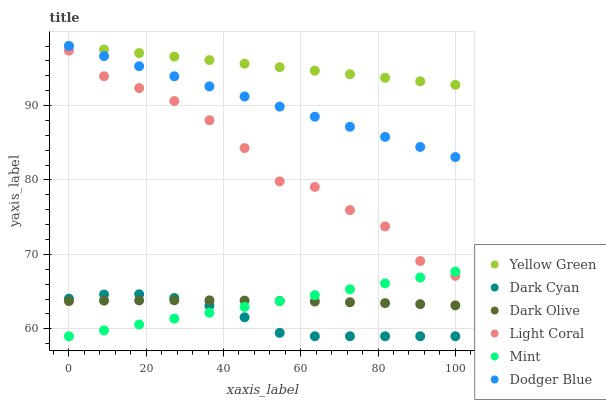Does Dark Cyan have the minimum area under the curve?
Answer yes or no. Yes. Does Yellow Green have the maximum area under the curve?
Answer yes or no. Yes. Does Dark Olive have the minimum area under the curve?
Answer yes or no. No. Does Dark Olive have the maximum area under the curve?
Answer yes or no. No. Is Yellow Green the smoothest?
Answer yes or no. Yes. Is Light Coral the roughest?
Answer yes or no. Yes. Is Dark Olive the smoothest?
Answer yes or no. No. Is Dark Olive the roughest?
Answer yes or no. No. Does Dark Cyan have the lowest value?
Answer yes or no. Yes. Does Dark Olive have the lowest value?
Answer yes or no. No. Does Dodger Blue have the highest value?
Answer yes or no. Yes. Does Light Coral have the highest value?
Answer yes or no. No. Is Dark Olive less than Dodger Blue?
Answer yes or no. Yes. Is Dodger Blue greater than Light Coral?
Answer yes or no. Yes. Does Dark Olive intersect Dark Cyan?
Answer yes or no. Yes. Is Dark Olive less than Dark Cyan?
Answer yes or no. No. Is Dark Olive greater than Dark Cyan?
Answer yes or no. No. Does Dark Olive intersect Dodger Blue?
Answer yes or no. No. 